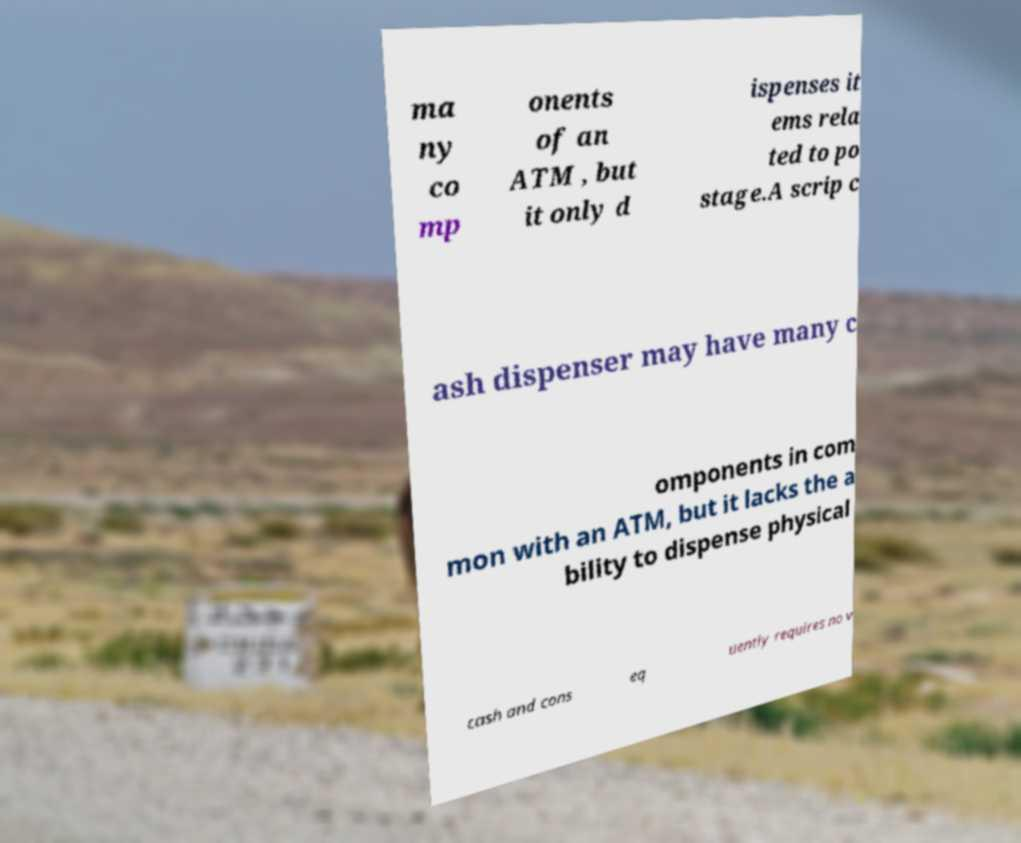Please identify and transcribe the text found in this image. ma ny co mp onents of an ATM , but it only d ispenses it ems rela ted to po stage.A scrip c ash dispenser may have many c omponents in com mon with an ATM, but it lacks the a bility to dispense physical cash and cons eq uently requires no v 